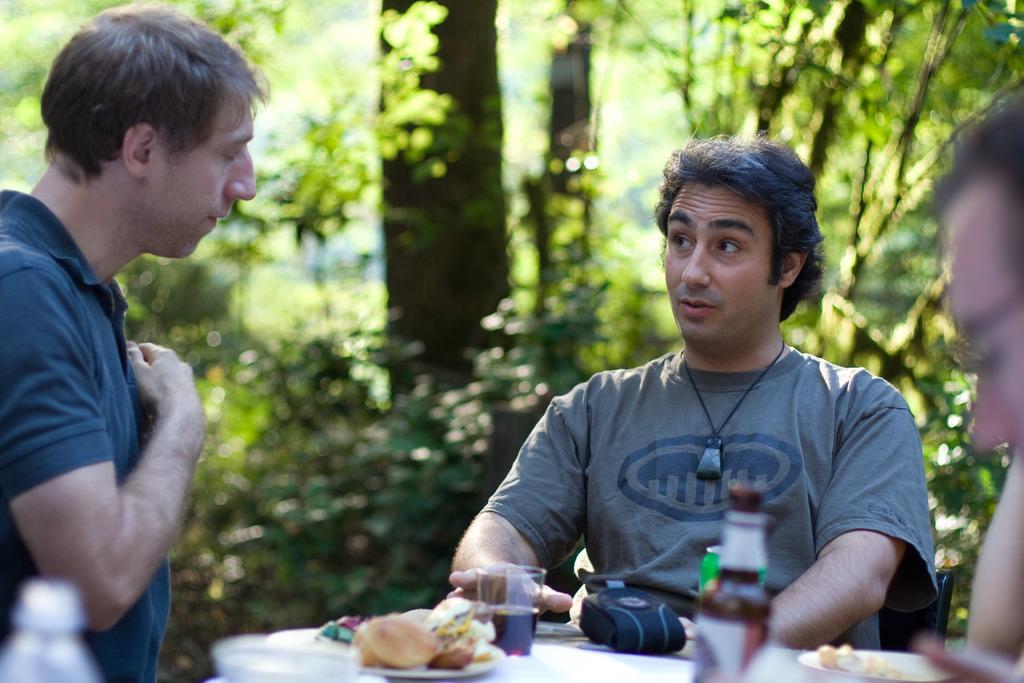Please provide a concise description of this image. In the middle of the picture, we see a man is sitting on the chair. In front of him, we see a table on which camera bag, glass, sauce bottle, plate containing food items are placed, The man on the left side is talking to the man. There are trees in the background. This picture is blurred in the background. 